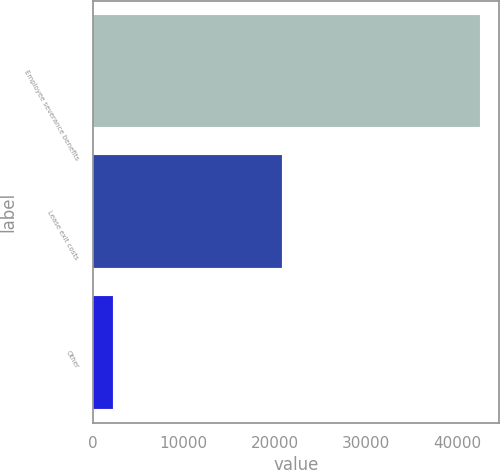Convert chart. <chart><loc_0><loc_0><loc_500><loc_500><bar_chart><fcel>Employee severance benefits<fcel>Lease exit costs<fcel>Other<nl><fcel>42499<fcel>20749<fcel>2194<nl></chart> 